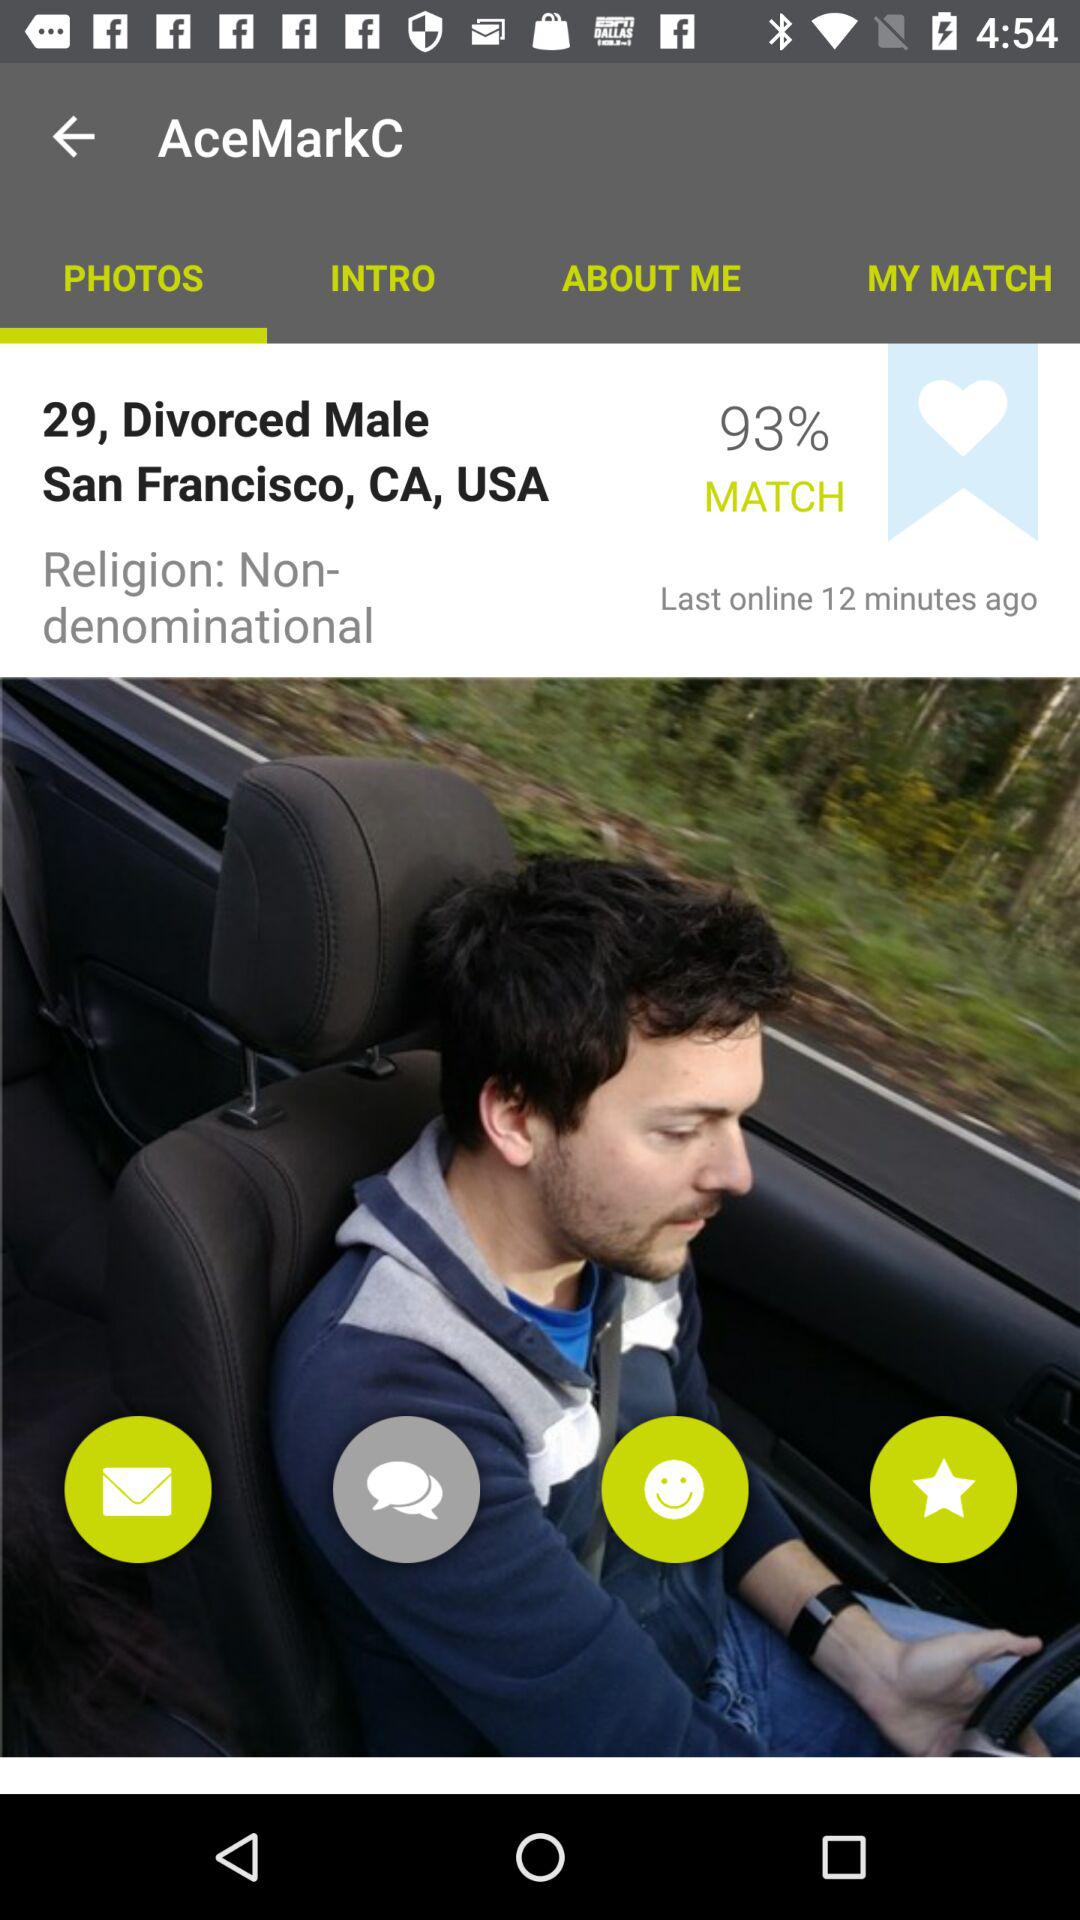What is the religion? The religion is "Non-denominational". 